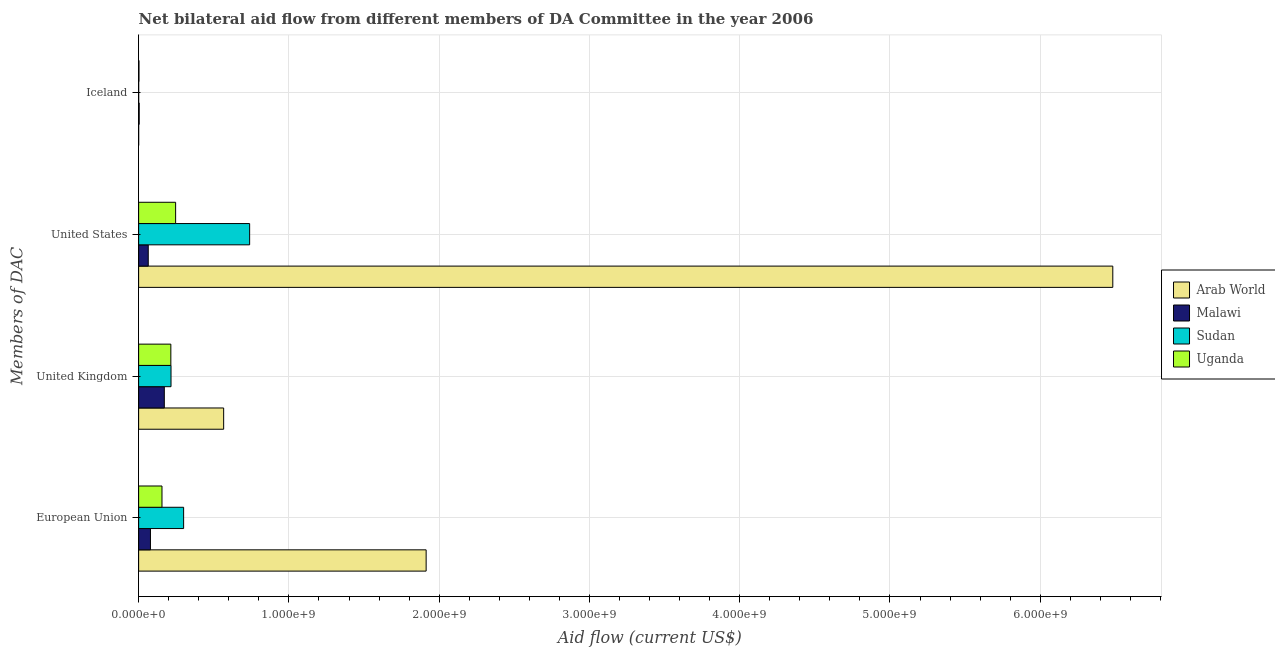Are the number of bars per tick equal to the number of legend labels?
Provide a short and direct response. Yes. Are the number of bars on each tick of the Y-axis equal?
Your response must be concise. Yes. How many bars are there on the 3rd tick from the bottom?
Offer a very short reply. 4. What is the amount of aid given by iceland in Arab World?
Provide a short and direct response. 1.40e+05. Across all countries, what is the maximum amount of aid given by us?
Make the answer very short. 6.48e+09. Across all countries, what is the minimum amount of aid given by eu?
Keep it short and to the point. 7.87e+07. In which country was the amount of aid given by eu maximum?
Offer a terse response. Arab World. In which country was the amount of aid given by eu minimum?
Your answer should be very brief. Malawi. What is the total amount of aid given by uk in the graph?
Your answer should be very brief. 1.17e+09. What is the difference between the amount of aid given by eu in Uganda and that in Sudan?
Your answer should be very brief. -1.44e+08. What is the difference between the amount of aid given by iceland in Uganda and the amount of aid given by uk in Malawi?
Your response must be concise. -1.69e+08. What is the average amount of aid given by uk per country?
Ensure brevity in your answer.  2.92e+08. What is the difference between the amount of aid given by iceland and amount of aid given by eu in Uganda?
Make the answer very short. -1.53e+08. In how many countries, is the amount of aid given by us greater than 1400000000 US$?
Provide a succinct answer. 1. What is the ratio of the amount of aid given by us in Sudan to that in Uganda?
Offer a terse response. 3. Is the difference between the amount of aid given by uk in Arab World and Sudan greater than the difference between the amount of aid given by us in Arab World and Sudan?
Provide a short and direct response. No. What is the difference between the highest and the second highest amount of aid given by iceland?
Provide a short and direct response. 1.45e+06. What is the difference between the highest and the lowest amount of aid given by iceland?
Offer a very short reply. 3.59e+06. What does the 1st bar from the top in Iceland represents?
Keep it short and to the point. Uganda. What does the 4th bar from the bottom in United States represents?
Offer a very short reply. Uganda. Is it the case that in every country, the sum of the amount of aid given by eu and amount of aid given by uk is greater than the amount of aid given by us?
Your answer should be very brief. No. Are the values on the major ticks of X-axis written in scientific E-notation?
Give a very brief answer. Yes. Does the graph contain any zero values?
Your response must be concise. No. How many legend labels are there?
Your response must be concise. 4. What is the title of the graph?
Your response must be concise. Net bilateral aid flow from different members of DA Committee in the year 2006. Does "Lesotho" appear as one of the legend labels in the graph?
Offer a terse response. No. What is the label or title of the Y-axis?
Make the answer very short. Members of DAC. What is the Aid flow (current US$) in Arab World in European Union?
Give a very brief answer. 1.91e+09. What is the Aid flow (current US$) in Malawi in European Union?
Provide a succinct answer. 7.87e+07. What is the Aid flow (current US$) of Sudan in European Union?
Make the answer very short. 2.99e+08. What is the Aid flow (current US$) in Uganda in European Union?
Provide a short and direct response. 1.55e+08. What is the Aid flow (current US$) of Arab World in United Kingdom?
Give a very brief answer. 5.66e+08. What is the Aid flow (current US$) in Malawi in United Kingdom?
Keep it short and to the point. 1.71e+08. What is the Aid flow (current US$) of Sudan in United Kingdom?
Give a very brief answer. 2.16e+08. What is the Aid flow (current US$) in Uganda in United Kingdom?
Your answer should be compact. 2.14e+08. What is the Aid flow (current US$) in Arab World in United States?
Give a very brief answer. 6.48e+09. What is the Aid flow (current US$) in Malawi in United States?
Make the answer very short. 6.40e+07. What is the Aid flow (current US$) in Sudan in United States?
Keep it short and to the point. 7.39e+08. What is the Aid flow (current US$) of Uganda in United States?
Make the answer very short. 2.46e+08. What is the Aid flow (current US$) of Arab World in Iceland?
Offer a terse response. 1.40e+05. What is the Aid flow (current US$) of Malawi in Iceland?
Offer a terse response. 3.73e+06. What is the Aid flow (current US$) in Uganda in Iceland?
Provide a short and direct response. 2.28e+06. Across all Members of DAC, what is the maximum Aid flow (current US$) of Arab World?
Your answer should be compact. 6.48e+09. Across all Members of DAC, what is the maximum Aid flow (current US$) in Malawi?
Offer a terse response. 1.71e+08. Across all Members of DAC, what is the maximum Aid flow (current US$) in Sudan?
Make the answer very short. 7.39e+08. Across all Members of DAC, what is the maximum Aid flow (current US$) in Uganda?
Your answer should be compact. 2.46e+08. Across all Members of DAC, what is the minimum Aid flow (current US$) of Malawi?
Keep it short and to the point. 3.73e+06. Across all Members of DAC, what is the minimum Aid flow (current US$) in Uganda?
Provide a succinct answer. 2.28e+06. What is the total Aid flow (current US$) of Arab World in the graph?
Your response must be concise. 8.96e+09. What is the total Aid flow (current US$) in Malawi in the graph?
Offer a very short reply. 3.17e+08. What is the total Aid flow (current US$) of Sudan in the graph?
Offer a terse response. 1.25e+09. What is the total Aid flow (current US$) in Uganda in the graph?
Your answer should be very brief. 6.18e+08. What is the difference between the Aid flow (current US$) of Arab World in European Union and that in United Kingdom?
Your response must be concise. 1.35e+09. What is the difference between the Aid flow (current US$) of Malawi in European Union and that in United Kingdom?
Make the answer very short. -9.23e+07. What is the difference between the Aid flow (current US$) in Sudan in European Union and that in United Kingdom?
Offer a very short reply. 8.39e+07. What is the difference between the Aid flow (current US$) in Uganda in European Union and that in United Kingdom?
Provide a short and direct response. -5.89e+07. What is the difference between the Aid flow (current US$) of Arab World in European Union and that in United States?
Give a very brief answer. -4.57e+09. What is the difference between the Aid flow (current US$) in Malawi in European Union and that in United States?
Keep it short and to the point. 1.46e+07. What is the difference between the Aid flow (current US$) in Sudan in European Union and that in United States?
Make the answer very short. -4.39e+08. What is the difference between the Aid flow (current US$) of Uganda in European Union and that in United States?
Your answer should be very brief. -9.08e+07. What is the difference between the Aid flow (current US$) of Arab World in European Union and that in Iceland?
Keep it short and to the point. 1.91e+09. What is the difference between the Aid flow (current US$) in Malawi in European Union and that in Iceland?
Offer a very short reply. 7.49e+07. What is the difference between the Aid flow (current US$) in Sudan in European Union and that in Iceland?
Your answer should be very brief. 2.99e+08. What is the difference between the Aid flow (current US$) in Uganda in European Union and that in Iceland?
Offer a terse response. 1.53e+08. What is the difference between the Aid flow (current US$) in Arab World in United Kingdom and that in United States?
Your answer should be very brief. -5.92e+09. What is the difference between the Aid flow (current US$) of Malawi in United Kingdom and that in United States?
Give a very brief answer. 1.07e+08. What is the difference between the Aid flow (current US$) in Sudan in United Kingdom and that in United States?
Keep it short and to the point. -5.23e+08. What is the difference between the Aid flow (current US$) of Uganda in United Kingdom and that in United States?
Make the answer very short. -3.18e+07. What is the difference between the Aid flow (current US$) of Arab World in United Kingdom and that in Iceland?
Keep it short and to the point. 5.66e+08. What is the difference between the Aid flow (current US$) in Malawi in United Kingdom and that in Iceland?
Your answer should be very brief. 1.67e+08. What is the difference between the Aid flow (current US$) in Sudan in United Kingdom and that in Iceland?
Offer a very short reply. 2.15e+08. What is the difference between the Aid flow (current US$) of Uganda in United Kingdom and that in Iceland?
Ensure brevity in your answer.  2.12e+08. What is the difference between the Aid flow (current US$) in Arab World in United States and that in Iceland?
Ensure brevity in your answer.  6.48e+09. What is the difference between the Aid flow (current US$) in Malawi in United States and that in Iceland?
Provide a succinct answer. 6.03e+07. What is the difference between the Aid flow (current US$) in Sudan in United States and that in Iceland?
Ensure brevity in your answer.  7.39e+08. What is the difference between the Aid flow (current US$) in Uganda in United States and that in Iceland?
Provide a short and direct response. 2.44e+08. What is the difference between the Aid flow (current US$) of Arab World in European Union and the Aid flow (current US$) of Malawi in United Kingdom?
Provide a succinct answer. 1.74e+09. What is the difference between the Aid flow (current US$) in Arab World in European Union and the Aid flow (current US$) in Sudan in United Kingdom?
Provide a succinct answer. 1.70e+09. What is the difference between the Aid flow (current US$) of Arab World in European Union and the Aid flow (current US$) of Uganda in United Kingdom?
Provide a short and direct response. 1.70e+09. What is the difference between the Aid flow (current US$) of Malawi in European Union and the Aid flow (current US$) of Sudan in United Kingdom?
Your response must be concise. -1.37e+08. What is the difference between the Aid flow (current US$) in Malawi in European Union and the Aid flow (current US$) in Uganda in United Kingdom?
Provide a short and direct response. -1.36e+08. What is the difference between the Aid flow (current US$) of Sudan in European Union and the Aid flow (current US$) of Uganda in United Kingdom?
Provide a succinct answer. 8.50e+07. What is the difference between the Aid flow (current US$) of Arab World in European Union and the Aid flow (current US$) of Malawi in United States?
Make the answer very short. 1.85e+09. What is the difference between the Aid flow (current US$) in Arab World in European Union and the Aid flow (current US$) in Sudan in United States?
Your answer should be very brief. 1.17e+09. What is the difference between the Aid flow (current US$) in Arab World in European Union and the Aid flow (current US$) in Uganda in United States?
Offer a terse response. 1.67e+09. What is the difference between the Aid flow (current US$) of Malawi in European Union and the Aid flow (current US$) of Sudan in United States?
Your response must be concise. -6.60e+08. What is the difference between the Aid flow (current US$) of Malawi in European Union and the Aid flow (current US$) of Uganda in United States?
Your answer should be compact. -1.68e+08. What is the difference between the Aid flow (current US$) of Sudan in European Union and the Aid flow (current US$) of Uganda in United States?
Keep it short and to the point. 5.32e+07. What is the difference between the Aid flow (current US$) in Arab World in European Union and the Aid flow (current US$) in Malawi in Iceland?
Offer a very short reply. 1.91e+09. What is the difference between the Aid flow (current US$) of Arab World in European Union and the Aid flow (current US$) of Sudan in Iceland?
Your answer should be compact. 1.91e+09. What is the difference between the Aid flow (current US$) of Arab World in European Union and the Aid flow (current US$) of Uganda in Iceland?
Your answer should be compact. 1.91e+09. What is the difference between the Aid flow (current US$) in Malawi in European Union and the Aid flow (current US$) in Sudan in Iceland?
Provide a short and direct response. 7.85e+07. What is the difference between the Aid flow (current US$) of Malawi in European Union and the Aid flow (current US$) of Uganda in Iceland?
Ensure brevity in your answer.  7.64e+07. What is the difference between the Aid flow (current US$) of Sudan in European Union and the Aid flow (current US$) of Uganda in Iceland?
Your answer should be compact. 2.97e+08. What is the difference between the Aid flow (current US$) in Arab World in United Kingdom and the Aid flow (current US$) in Malawi in United States?
Provide a short and direct response. 5.02e+08. What is the difference between the Aid flow (current US$) in Arab World in United Kingdom and the Aid flow (current US$) in Sudan in United States?
Provide a succinct answer. -1.73e+08. What is the difference between the Aid flow (current US$) in Arab World in United Kingdom and the Aid flow (current US$) in Uganda in United States?
Your answer should be compact. 3.20e+08. What is the difference between the Aid flow (current US$) in Malawi in United Kingdom and the Aid flow (current US$) in Sudan in United States?
Provide a succinct answer. -5.68e+08. What is the difference between the Aid flow (current US$) of Malawi in United Kingdom and the Aid flow (current US$) of Uganda in United States?
Make the answer very short. -7.53e+07. What is the difference between the Aid flow (current US$) of Sudan in United Kingdom and the Aid flow (current US$) of Uganda in United States?
Your response must be concise. -3.07e+07. What is the difference between the Aid flow (current US$) of Arab World in United Kingdom and the Aid flow (current US$) of Malawi in Iceland?
Offer a very short reply. 5.62e+08. What is the difference between the Aid flow (current US$) of Arab World in United Kingdom and the Aid flow (current US$) of Sudan in Iceland?
Provide a succinct answer. 5.66e+08. What is the difference between the Aid flow (current US$) of Arab World in United Kingdom and the Aid flow (current US$) of Uganda in Iceland?
Make the answer very short. 5.64e+08. What is the difference between the Aid flow (current US$) of Malawi in United Kingdom and the Aid flow (current US$) of Sudan in Iceland?
Offer a terse response. 1.71e+08. What is the difference between the Aid flow (current US$) of Malawi in United Kingdom and the Aid flow (current US$) of Uganda in Iceland?
Make the answer very short. 1.69e+08. What is the difference between the Aid flow (current US$) of Sudan in United Kingdom and the Aid flow (current US$) of Uganda in Iceland?
Ensure brevity in your answer.  2.13e+08. What is the difference between the Aid flow (current US$) of Arab World in United States and the Aid flow (current US$) of Malawi in Iceland?
Provide a short and direct response. 6.48e+09. What is the difference between the Aid flow (current US$) in Arab World in United States and the Aid flow (current US$) in Sudan in Iceland?
Provide a short and direct response. 6.48e+09. What is the difference between the Aid flow (current US$) of Arab World in United States and the Aid flow (current US$) of Uganda in Iceland?
Offer a very short reply. 6.48e+09. What is the difference between the Aid flow (current US$) of Malawi in United States and the Aid flow (current US$) of Sudan in Iceland?
Your answer should be compact. 6.39e+07. What is the difference between the Aid flow (current US$) of Malawi in United States and the Aid flow (current US$) of Uganda in Iceland?
Offer a very short reply. 6.17e+07. What is the difference between the Aid flow (current US$) in Sudan in United States and the Aid flow (current US$) in Uganda in Iceland?
Ensure brevity in your answer.  7.36e+08. What is the average Aid flow (current US$) of Arab World per Members of DAC?
Your answer should be compact. 2.24e+09. What is the average Aid flow (current US$) of Malawi per Members of DAC?
Your answer should be very brief. 7.93e+07. What is the average Aid flow (current US$) in Sudan per Members of DAC?
Keep it short and to the point. 3.13e+08. What is the average Aid flow (current US$) in Uganda per Members of DAC?
Your answer should be very brief. 1.55e+08. What is the difference between the Aid flow (current US$) of Arab World and Aid flow (current US$) of Malawi in European Union?
Your answer should be very brief. 1.83e+09. What is the difference between the Aid flow (current US$) in Arab World and Aid flow (current US$) in Sudan in European Union?
Your response must be concise. 1.61e+09. What is the difference between the Aid flow (current US$) of Arab World and Aid flow (current US$) of Uganda in European Union?
Make the answer very short. 1.76e+09. What is the difference between the Aid flow (current US$) of Malawi and Aid flow (current US$) of Sudan in European Union?
Provide a succinct answer. -2.21e+08. What is the difference between the Aid flow (current US$) in Malawi and Aid flow (current US$) in Uganda in European Union?
Keep it short and to the point. -7.68e+07. What is the difference between the Aid flow (current US$) of Sudan and Aid flow (current US$) of Uganda in European Union?
Ensure brevity in your answer.  1.44e+08. What is the difference between the Aid flow (current US$) in Arab World and Aid flow (current US$) in Malawi in United Kingdom?
Offer a terse response. 3.95e+08. What is the difference between the Aid flow (current US$) of Arab World and Aid flow (current US$) of Sudan in United Kingdom?
Your response must be concise. 3.50e+08. What is the difference between the Aid flow (current US$) in Arab World and Aid flow (current US$) in Uganda in United Kingdom?
Your response must be concise. 3.51e+08. What is the difference between the Aid flow (current US$) in Malawi and Aid flow (current US$) in Sudan in United Kingdom?
Provide a short and direct response. -4.46e+07. What is the difference between the Aid flow (current US$) of Malawi and Aid flow (current US$) of Uganda in United Kingdom?
Your response must be concise. -4.35e+07. What is the difference between the Aid flow (current US$) of Sudan and Aid flow (current US$) of Uganda in United Kingdom?
Ensure brevity in your answer.  1.14e+06. What is the difference between the Aid flow (current US$) of Arab World and Aid flow (current US$) of Malawi in United States?
Make the answer very short. 6.42e+09. What is the difference between the Aid flow (current US$) in Arab World and Aid flow (current US$) in Sudan in United States?
Offer a terse response. 5.74e+09. What is the difference between the Aid flow (current US$) in Arab World and Aid flow (current US$) in Uganda in United States?
Your answer should be very brief. 6.24e+09. What is the difference between the Aid flow (current US$) in Malawi and Aid flow (current US$) in Sudan in United States?
Ensure brevity in your answer.  -6.75e+08. What is the difference between the Aid flow (current US$) in Malawi and Aid flow (current US$) in Uganda in United States?
Your answer should be compact. -1.82e+08. What is the difference between the Aid flow (current US$) in Sudan and Aid flow (current US$) in Uganda in United States?
Provide a short and direct response. 4.93e+08. What is the difference between the Aid flow (current US$) of Arab World and Aid flow (current US$) of Malawi in Iceland?
Provide a short and direct response. -3.59e+06. What is the difference between the Aid flow (current US$) of Arab World and Aid flow (current US$) of Sudan in Iceland?
Provide a short and direct response. 0. What is the difference between the Aid flow (current US$) of Arab World and Aid flow (current US$) of Uganda in Iceland?
Give a very brief answer. -2.14e+06. What is the difference between the Aid flow (current US$) in Malawi and Aid flow (current US$) in Sudan in Iceland?
Keep it short and to the point. 3.59e+06. What is the difference between the Aid flow (current US$) of Malawi and Aid flow (current US$) of Uganda in Iceland?
Offer a terse response. 1.45e+06. What is the difference between the Aid flow (current US$) in Sudan and Aid flow (current US$) in Uganda in Iceland?
Give a very brief answer. -2.14e+06. What is the ratio of the Aid flow (current US$) in Arab World in European Union to that in United Kingdom?
Your answer should be very brief. 3.38. What is the ratio of the Aid flow (current US$) in Malawi in European Union to that in United Kingdom?
Give a very brief answer. 0.46. What is the ratio of the Aid flow (current US$) in Sudan in European Union to that in United Kingdom?
Offer a terse response. 1.39. What is the ratio of the Aid flow (current US$) in Uganda in European Union to that in United Kingdom?
Your response must be concise. 0.73. What is the ratio of the Aid flow (current US$) in Arab World in European Union to that in United States?
Keep it short and to the point. 0.3. What is the ratio of the Aid flow (current US$) in Malawi in European Union to that in United States?
Keep it short and to the point. 1.23. What is the ratio of the Aid flow (current US$) in Sudan in European Union to that in United States?
Offer a very short reply. 0.41. What is the ratio of the Aid flow (current US$) of Uganda in European Union to that in United States?
Give a very brief answer. 0.63. What is the ratio of the Aid flow (current US$) of Arab World in European Union to that in Iceland?
Provide a short and direct response. 1.37e+04. What is the ratio of the Aid flow (current US$) of Malawi in European Union to that in Iceland?
Offer a terse response. 21.09. What is the ratio of the Aid flow (current US$) in Sudan in European Union to that in Iceland?
Your response must be concise. 2138.64. What is the ratio of the Aid flow (current US$) of Uganda in European Union to that in Iceland?
Your answer should be compact. 68.19. What is the ratio of the Aid flow (current US$) in Arab World in United Kingdom to that in United States?
Give a very brief answer. 0.09. What is the ratio of the Aid flow (current US$) of Malawi in United Kingdom to that in United States?
Ensure brevity in your answer.  2.67. What is the ratio of the Aid flow (current US$) of Sudan in United Kingdom to that in United States?
Offer a very short reply. 0.29. What is the ratio of the Aid flow (current US$) of Uganda in United Kingdom to that in United States?
Your answer should be compact. 0.87. What is the ratio of the Aid flow (current US$) in Arab World in United Kingdom to that in Iceland?
Your answer should be compact. 4041.64. What is the ratio of the Aid flow (current US$) of Malawi in United Kingdom to that in Iceland?
Offer a very short reply. 45.83. What is the ratio of the Aid flow (current US$) in Sudan in United Kingdom to that in Iceland?
Ensure brevity in your answer.  1539.64. What is the ratio of the Aid flow (current US$) of Uganda in United Kingdom to that in Iceland?
Your answer should be very brief. 94.04. What is the ratio of the Aid flow (current US$) in Arab World in United States to that in Iceland?
Offer a terse response. 4.63e+04. What is the ratio of the Aid flow (current US$) in Malawi in United States to that in Iceland?
Keep it short and to the point. 17.16. What is the ratio of the Aid flow (current US$) of Sudan in United States to that in Iceland?
Offer a very short reply. 5277. What is the ratio of the Aid flow (current US$) of Uganda in United States to that in Iceland?
Give a very brief answer. 107.99. What is the difference between the highest and the second highest Aid flow (current US$) in Arab World?
Give a very brief answer. 4.57e+09. What is the difference between the highest and the second highest Aid flow (current US$) of Malawi?
Offer a very short reply. 9.23e+07. What is the difference between the highest and the second highest Aid flow (current US$) of Sudan?
Make the answer very short. 4.39e+08. What is the difference between the highest and the second highest Aid flow (current US$) in Uganda?
Provide a short and direct response. 3.18e+07. What is the difference between the highest and the lowest Aid flow (current US$) of Arab World?
Provide a succinct answer. 6.48e+09. What is the difference between the highest and the lowest Aid flow (current US$) in Malawi?
Keep it short and to the point. 1.67e+08. What is the difference between the highest and the lowest Aid flow (current US$) in Sudan?
Your response must be concise. 7.39e+08. What is the difference between the highest and the lowest Aid flow (current US$) in Uganda?
Make the answer very short. 2.44e+08. 